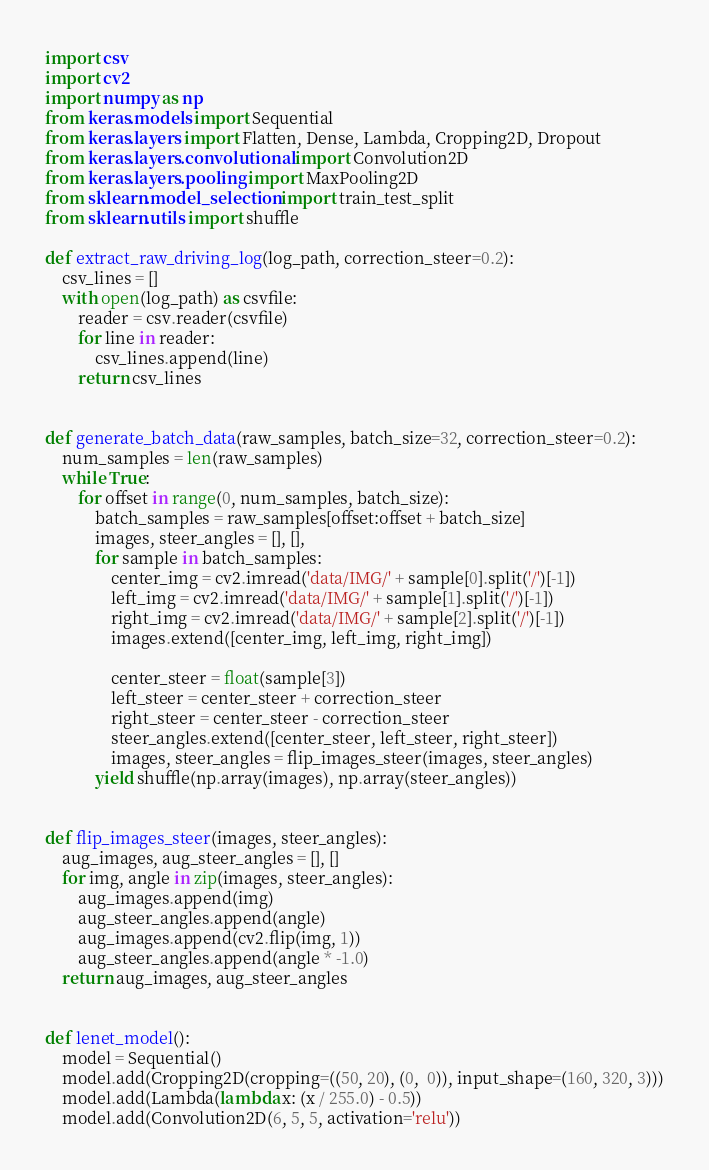Convert code to text. <code><loc_0><loc_0><loc_500><loc_500><_Python_>import csv
import cv2
import numpy as np
from keras.models import Sequential
from keras.layers import Flatten, Dense, Lambda, Cropping2D, Dropout
from keras.layers.convolutional import Convolution2D
from keras.layers.pooling import MaxPooling2D
from sklearn.model_selection import train_test_split
from sklearn.utils import shuffle

def extract_raw_driving_log(log_path, correction_steer=0.2):
    csv_lines = []
    with open(log_path) as csvfile:
        reader = csv.reader(csvfile)
        for line in reader:
            csv_lines.append(line)
        return csv_lines


def generate_batch_data(raw_samples, batch_size=32, correction_steer=0.2):
    num_samples = len(raw_samples)
    while True:
        for offset in range(0, num_samples, batch_size):
            batch_samples = raw_samples[offset:offset + batch_size]
            images, steer_angles = [], [],
            for sample in batch_samples:
                center_img = cv2.imread('data/IMG/' + sample[0].split('/')[-1])
                left_img = cv2.imread('data/IMG/' + sample[1].split('/')[-1])
                right_img = cv2.imread('data/IMG/' + sample[2].split('/')[-1])
                images.extend([center_img, left_img, right_img])

                center_steer = float(sample[3])
                left_steer = center_steer + correction_steer
                right_steer = center_steer - correction_steer
                steer_angles.extend([center_steer, left_steer, right_steer])
                images, steer_angles = flip_images_steer(images, steer_angles)
            yield shuffle(np.array(images), np.array(steer_angles))


def flip_images_steer(images, steer_angles):
    aug_images, aug_steer_angles = [], []
    for img, angle in zip(images, steer_angles):
        aug_images.append(img)
        aug_steer_angles.append(angle)
        aug_images.append(cv2.flip(img, 1))
        aug_steer_angles.append(angle * -1.0)
    return aug_images, aug_steer_angles


def lenet_model():
    model = Sequential()
    model.add(Cropping2D(cropping=((50, 20), (0,  0)), input_shape=(160, 320, 3)))
    model.add(Lambda(lambda x: (x / 255.0) - 0.5))
    model.add(Convolution2D(6, 5, 5, activation='relu'))</code> 